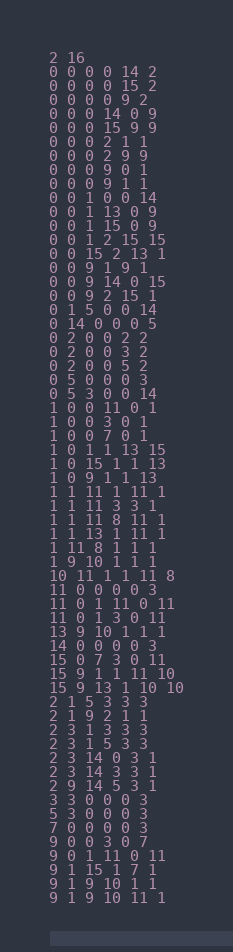Convert code to text. <code><loc_0><loc_0><loc_500><loc_500><_SQL_>2 16
0 0 0 0 14 2
0 0 0 0 15 2
0 0 0 0 9 2
0 0 0 14 0 9
0 0 0 15 9 9
0 0 0 2 1 1
0 0 0 2 9 9
0 0 0 9 0 1
0 0 0 9 1 1
0 0 1 0 0 14
0 0 1 13 0 9
0 0 1 15 0 9
0 0 1 2 15 15
0 0 15 2 13 1
0 0 9 1 9 1
0 0 9 14 0 15
0 0 9 2 15 1
0 1 5 0 0 14
0 14 0 0 0 5
0 2 0 0 2 2
0 2 0 0 3 2
0 2 0 0 5 2
0 5 0 0 0 3
0 5 3 0 0 14
1 0 0 11 0 1
1 0 0 3 0 1
1 0 0 7 0 1
1 0 1 1 13 15
1 0 15 1 1 13
1 0 9 1 1 13
1 1 11 1 11 1
1 1 11 3 3 1
1 1 11 8 11 1
1 1 13 1 11 1
1 11 8 1 1 1
1 9 10 1 1 1
10 11 1 1 11 8
11 0 0 0 0 3
11 0 1 11 0 11
11 0 1 3 0 11
13 9 10 1 1 1
14 0 0 0 0 3
15 0 7 3 0 11
15 9 1 1 11 10
15 9 13 1 10 10
2 1 5 3 3 3
2 1 9 2 1 1
2 3 1 3 3 3
2 3 1 5 3 3
2 3 14 0 3 1
2 3 14 3 3 1
2 9 14 5 3 1
3 3 0 0 0 3
5 3 0 0 0 3
7 0 0 0 0 3
9 0 0 3 0 7
9 0 1 11 0 11
9 1 15 1 7 1
9 1 9 10 1 1
9 1 9 10 11 1
</code> 